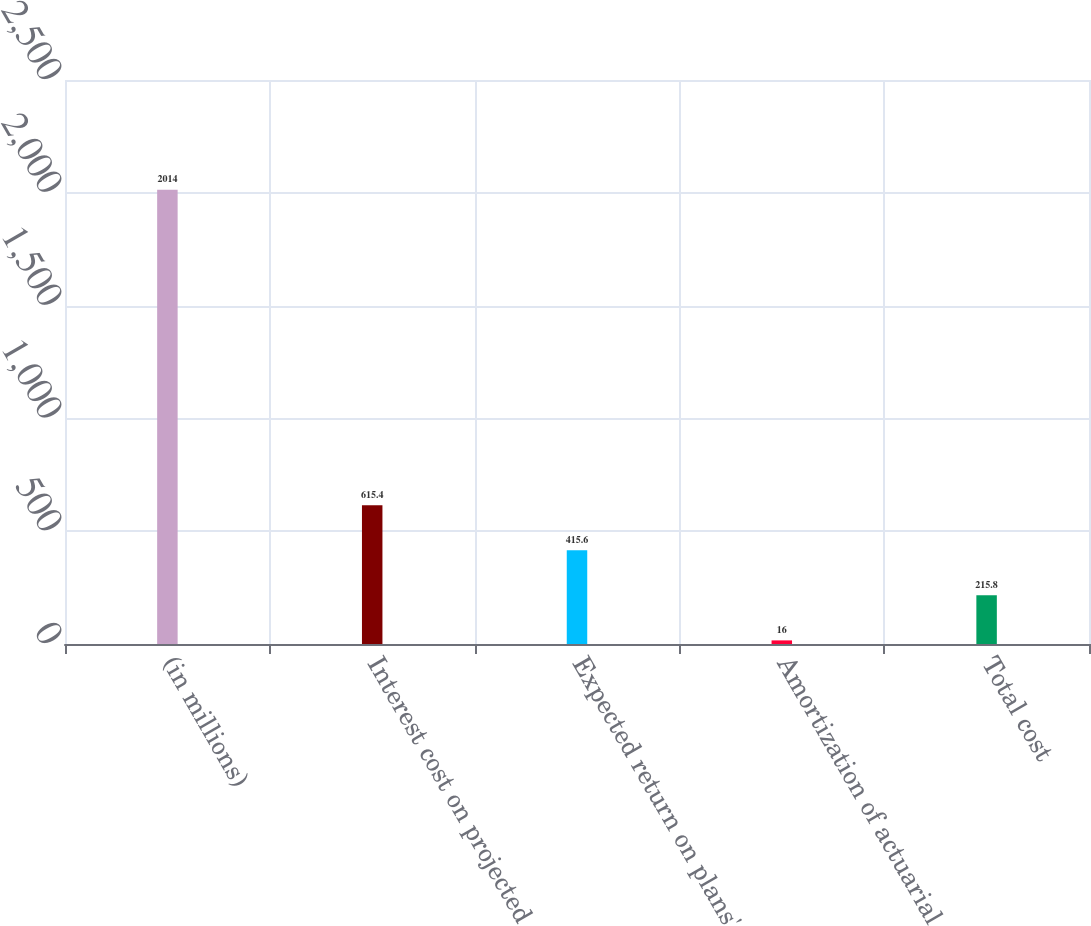<chart> <loc_0><loc_0><loc_500><loc_500><bar_chart><fcel>(in millions)<fcel>Interest cost on projected<fcel>Expected return on plans'<fcel>Amortization of actuarial<fcel>Total cost<nl><fcel>2014<fcel>615.4<fcel>415.6<fcel>16<fcel>215.8<nl></chart> 